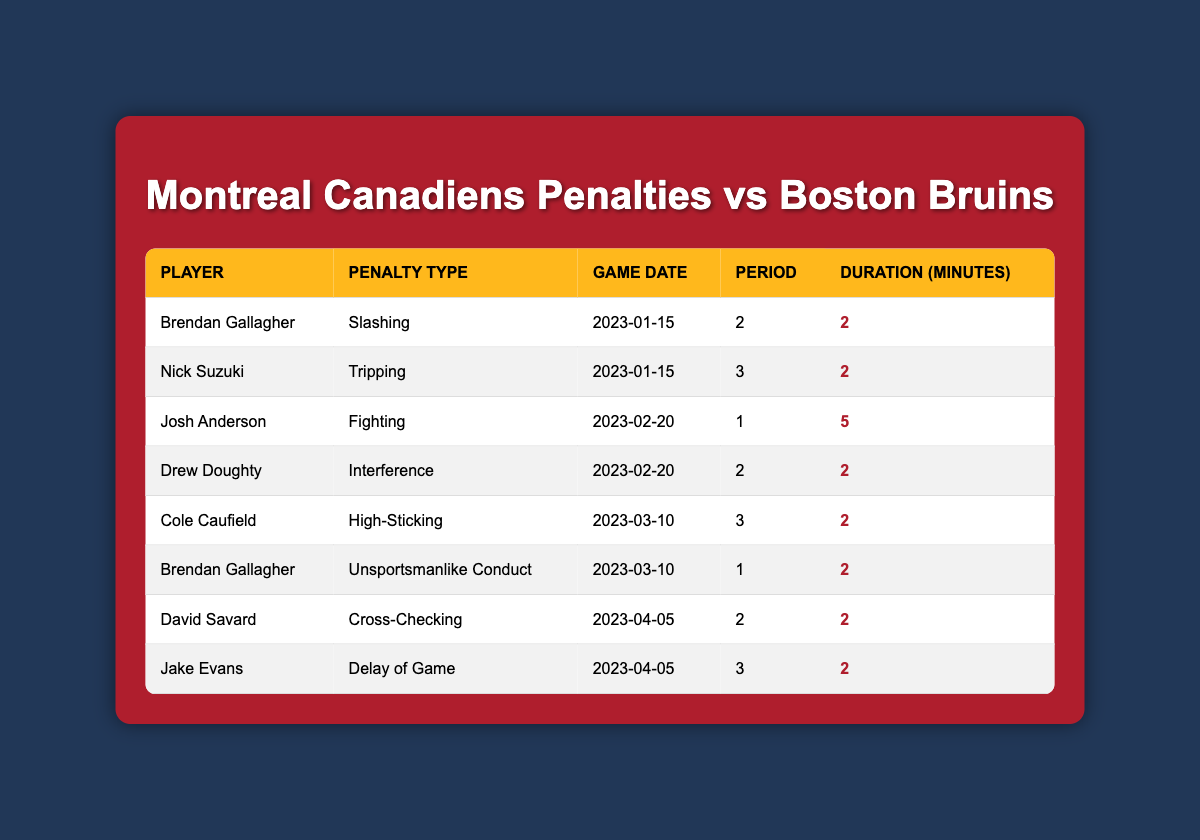What are the different types of penalties incurred by the Montreal Canadiens against the Boston Bruins? The table lists various penalties, including Slashing, Tripping, Fighting, Interference, High-Sticking, Unsportsmanlike Conduct, Cross-Checking, and Delay of Game. Each penalty type corresponds to a separate incident involving a player.
Answer: Slashing, Tripping, Fighting, Interference, High-Sticking, Unsportsmanlike Conduct, Cross-Checking, Delay of Game How many times did Brendan Gallagher incur a penalty in the games? Brendan Gallagher is listed twice in the table, once for Slashing and once for Unsportsmanlike Conduct, indicating he incurred penalties in two separate games.
Answer: 2 What was the total duration of penalties incurred by Nick Suzuki? Nick Suzuki has only one penalty listed in the table (Tripping) with a duration of 2 minutes. Thus, the total duration is simply the value of that single penalty.
Answer: 2 Did the Montreal Canadiens incur a Fighting penalty? The table includes one instance of a Fighting penalty, which was incurred by Josh Anderson on February 20, 2023. Therefore, the statement is true.
Answer: Yes Which player incurred the longest penalty duration and what was it? The longest penalty duration listed is 5 minutes incurred by Josh Anderson for Fighting on February 20, 2023. This can be determined by comparing the duration of penalties across all players.
Answer: Josh Anderson, 5 minutes What was the average penalty duration for the Montreal Canadiens in the games against the Boston Bruins? The total duration of penalties is calculated by adding all the penalty durations: 2 + 2 + 5 + 2 + 2 + 2 + 2 + 2 = 19 minutes. There are 8 penalties, so the average is 19/8 = 2.375 minutes.
Answer: 2.375 How many players incurred penalties during the specified games against the Boston Bruins? By reviewing the table, there are 8 distinct entries, but "Brendan Gallagher" appears twice. Therefore, the total number of unique players can be calculated as 7 by listing them only once.
Answer: 7 Was there any penalty incurred in the first period? Yes, the table shows that Josh Anderson incurred a Fighting penalty in the 1st period of the game on February 20, 2023. This is verified by checking the Period column of each entry in the table.
Answer: Yes 